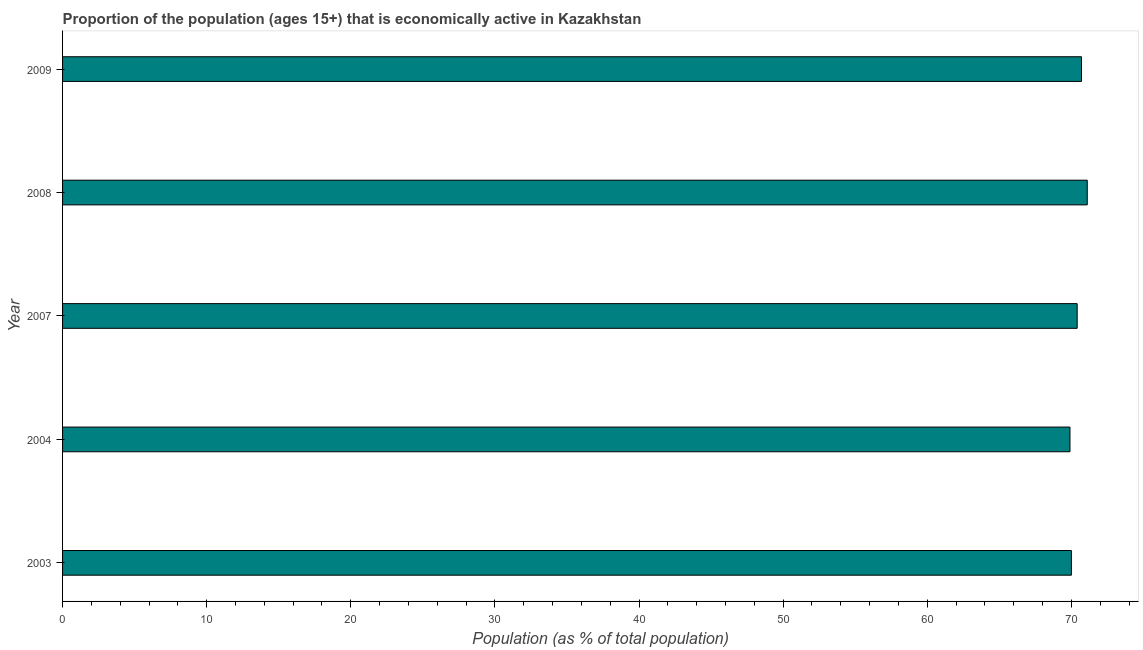Does the graph contain any zero values?
Make the answer very short. No. What is the title of the graph?
Your response must be concise. Proportion of the population (ages 15+) that is economically active in Kazakhstan. What is the label or title of the X-axis?
Provide a short and direct response. Population (as % of total population). What is the label or title of the Y-axis?
Your response must be concise. Year. What is the percentage of economically active population in 2008?
Your answer should be very brief. 71.1. Across all years, what is the maximum percentage of economically active population?
Provide a succinct answer. 71.1. Across all years, what is the minimum percentage of economically active population?
Your answer should be compact. 69.9. What is the sum of the percentage of economically active population?
Your response must be concise. 352.1. What is the average percentage of economically active population per year?
Provide a short and direct response. 70.42. What is the median percentage of economically active population?
Your answer should be compact. 70.4. Do a majority of the years between 2003 and 2007 (inclusive) have percentage of economically active population greater than 40 %?
Keep it short and to the point. Yes. Is the percentage of economically active population in 2008 less than that in 2009?
Provide a succinct answer. No. Is the difference between the percentage of economically active population in 2007 and 2009 greater than the difference between any two years?
Your response must be concise. No. In how many years, is the percentage of economically active population greater than the average percentage of economically active population taken over all years?
Offer a very short reply. 2. Are all the bars in the graph horizontal?
Your response must be concise. Yes. What is the Population (as % of total population) of 2003?
Offer a very short reply. 70. What is the Population (as % of total population) in 2004?
Provide a short and direct response. 69.9. What is the Population (as % of total population) of 2007?
Ensure brevity in your answer.  70.4. What is the Population (as % of total population) in 2008?
Make the answer very short. 71.1. What is the Population (as % of total population) in 2009?
Provide a succinct answer. 70.7. What is the difference between the Population (as % of total population) in 2003 and 2008?
Provide a short and direct response. -1.1. What is the difference between the Population (as % of total population) in 2007 and 2008?
Your answer should be very brief. -0.7. What is the difference between the Population (as % of total population) in 2007 and 2009?
Keep it short and to the point. -0.3. What is the difference between the Population (as % of total population) in 2008 and 2009?
Ensure brevity in your answer.  0.4. What is the ratio of the Population (as % of total population) in 2003 to that in 2004?
Your answer should be very brief. 1. What is the ratio of the Population (as % of total population) in 2003 to that in 2009?
Ensure brevity in your answer.  0.99. What is the ratio of the Population (as % of total population) in 2004 to that in 2007?
Provide a succinct answer. 0.99. What is the ratio of the Population (as % of total population) in 2007 to that in 2008?
Keep it short and to the point. 0.99. What is the ratio of the Population (as % of total population) in 2007 to that in 2009?
Offer a very short reply. 1. What is the ratio of the Population (as % of total population) in 2008 to that in 2009?
Offer a very short reply. 1.01. 